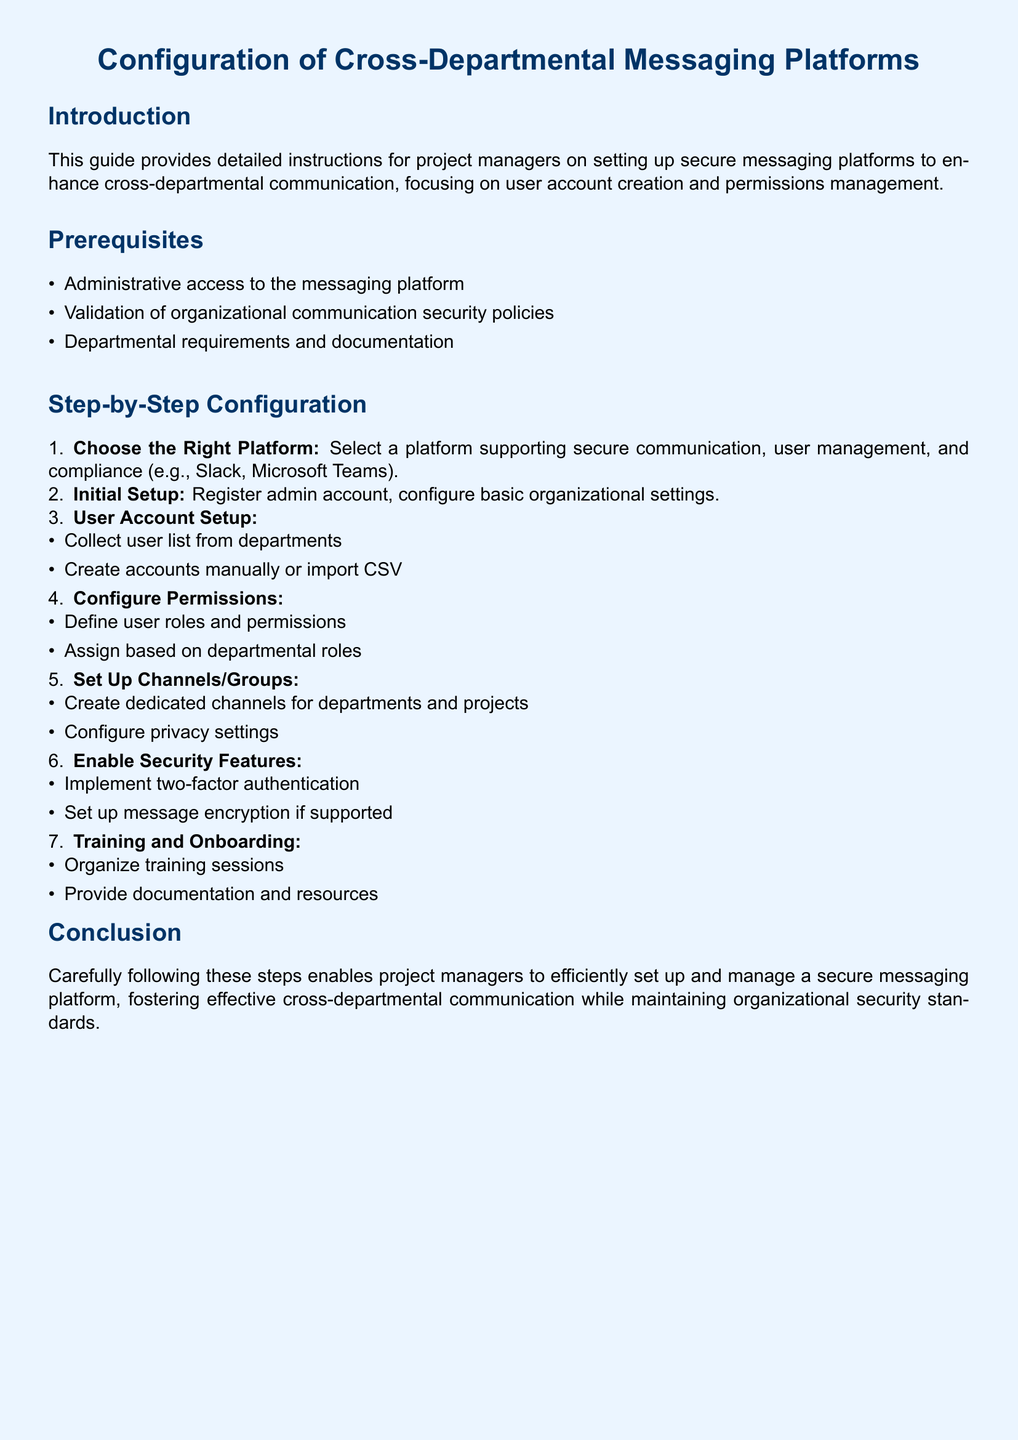What is the title of the document? The title is prominently displayed at the beginning of the document, which is "Configuration of Cross-Departmental Messaging Platforms."
Answer: Configuration of Cross-Departmental Messaging Platforms How many prerequisites are listed? The document enumerates the items under prerequisites, indicating there are three listed.
Answer: 3 What is the first step in the configuration process? The steps are numbered, and the first step is about choosing the right platform.
Answer: Choose the Right Platform What security feature should be enabled for user accounts? The document specifies a security feature that enhances account security, which is two-factor authentication.
Answer: Two-factor authentication What needs to be done after user account setup? Following the user account setup, the next action mentioned focuses on configuring permissions.
Answer: Configure Permissions What type of training should be organized? The document outlines a specific training activity necessary for onboarding, which is training sessions.
Answer: Training sessions What is the purpose of the channels/groups set up in the document? The creation of dedicated channels/groups is necessary for better communication among departments and projects.
Answer: Effective cross-departmental communication How are user roles defined in the configuration? User roles are specified based on departmental roles according to the instructions in the document.
Answer: Based on departmental roles 